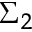<formula> <loc_0><loc_0><loc_500><loc_500>\Sigma _ { 2 }</formula> 